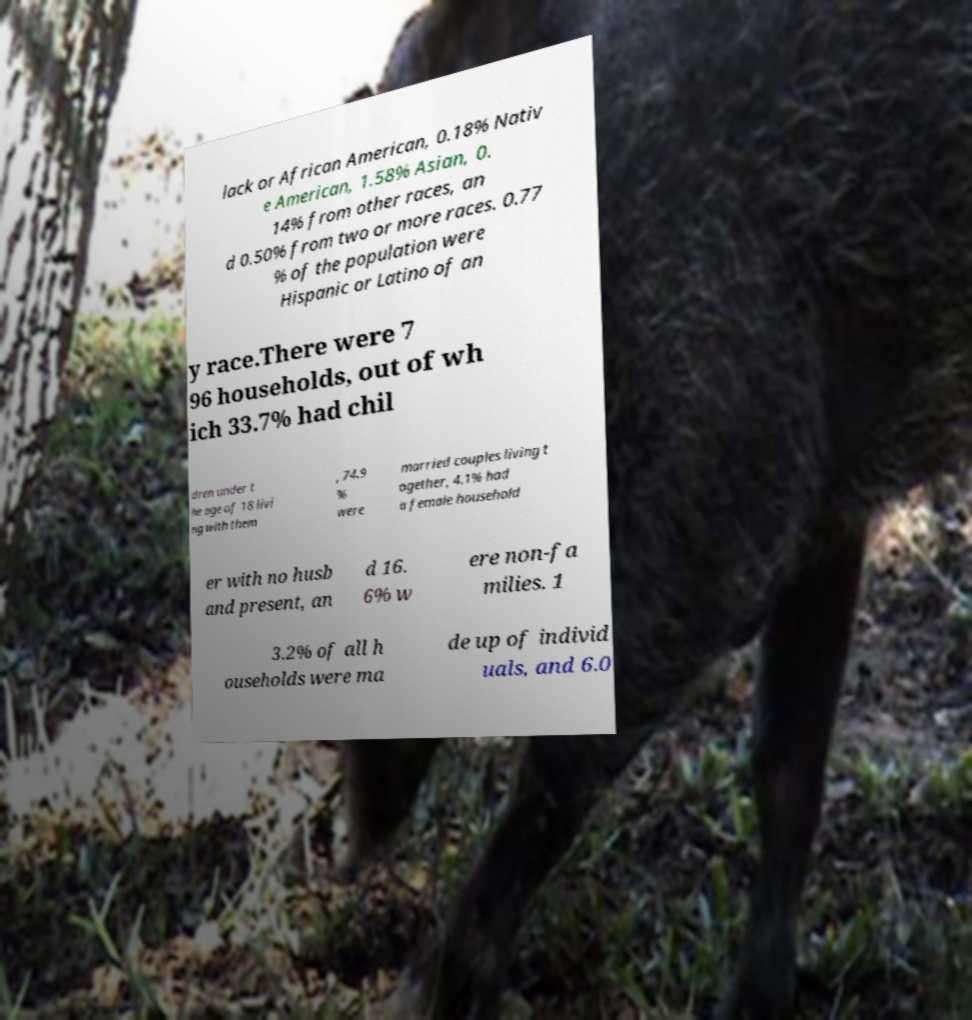Please read and relay the text visible in this image. What does it say? lack or African American, 0.18% Nativ e American, 1.58% Asian, 0. 14% from other races, an d 0.50% from two or more races. 0.77 % of the population were Hispanic or Latino of an y race.There were 7 96 households, out of wh ich 33.7% had chil dren under t he age of 18 livi ng with them , 74.9 % were married couples living t ogether, 4.1% had a female household er with no husb and present, an d 16. 6% w ere non-fa milies. 1 3.2% of all h ouseholds were ma de up of individ uals, and 6.0 